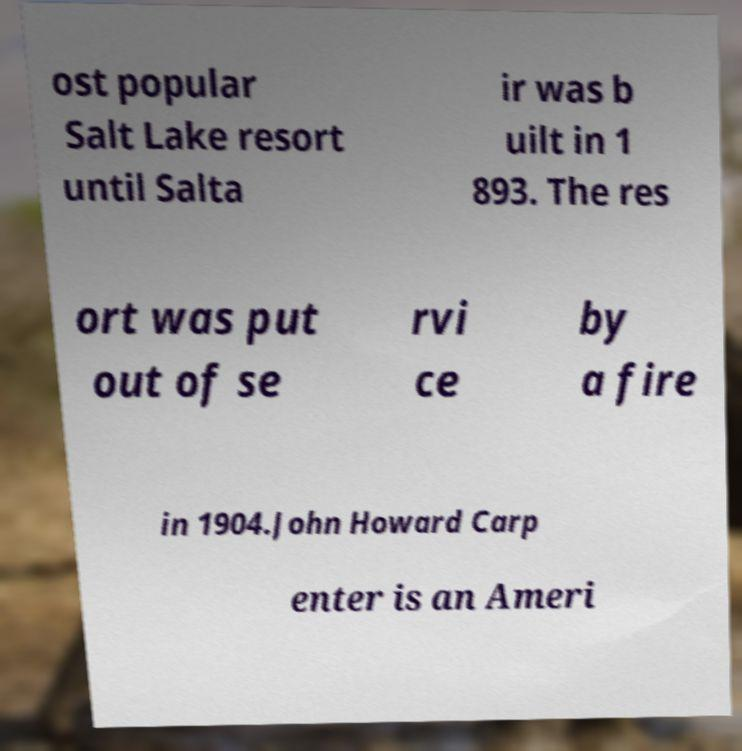What messages or text are displayed in this image? I need them in a readable, typed format. ost popular Salt Lake resort until Salta ir was b uilt in 1 893. The res ort was put out of se rvi ce by a fire in 1904.John Howard Carp enter is an Ameri 